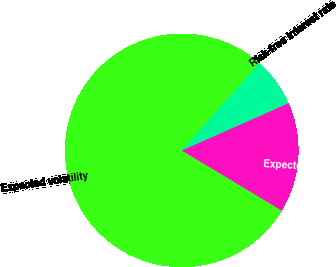<chart> <loc_0><loc_0><loc_500><loc_500><pie_chart><fcel>Expected volatility<fcel>Expected dividend yield<fcel>Risk-free interest rate<nl><fcel>77.97%<fcel>15.25%<fcel>6.78%<nl></chart> 